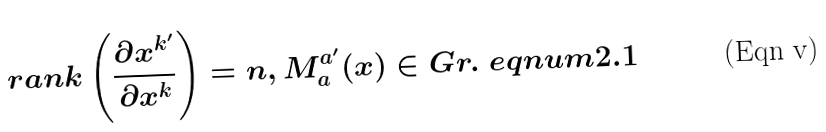Convert formula to latex. <formula><loc_0><loc_0><loc_500><loc_500>r a n k \left ( \frac { \partial x ^ { k ^ { \prime } } } { \partial x ^ { k } } \right ) = n , M _ { a } ^ { a ^ { \prime } } ( x ) \in G r . \ e q n u m { 2 . 1 }</formula> 